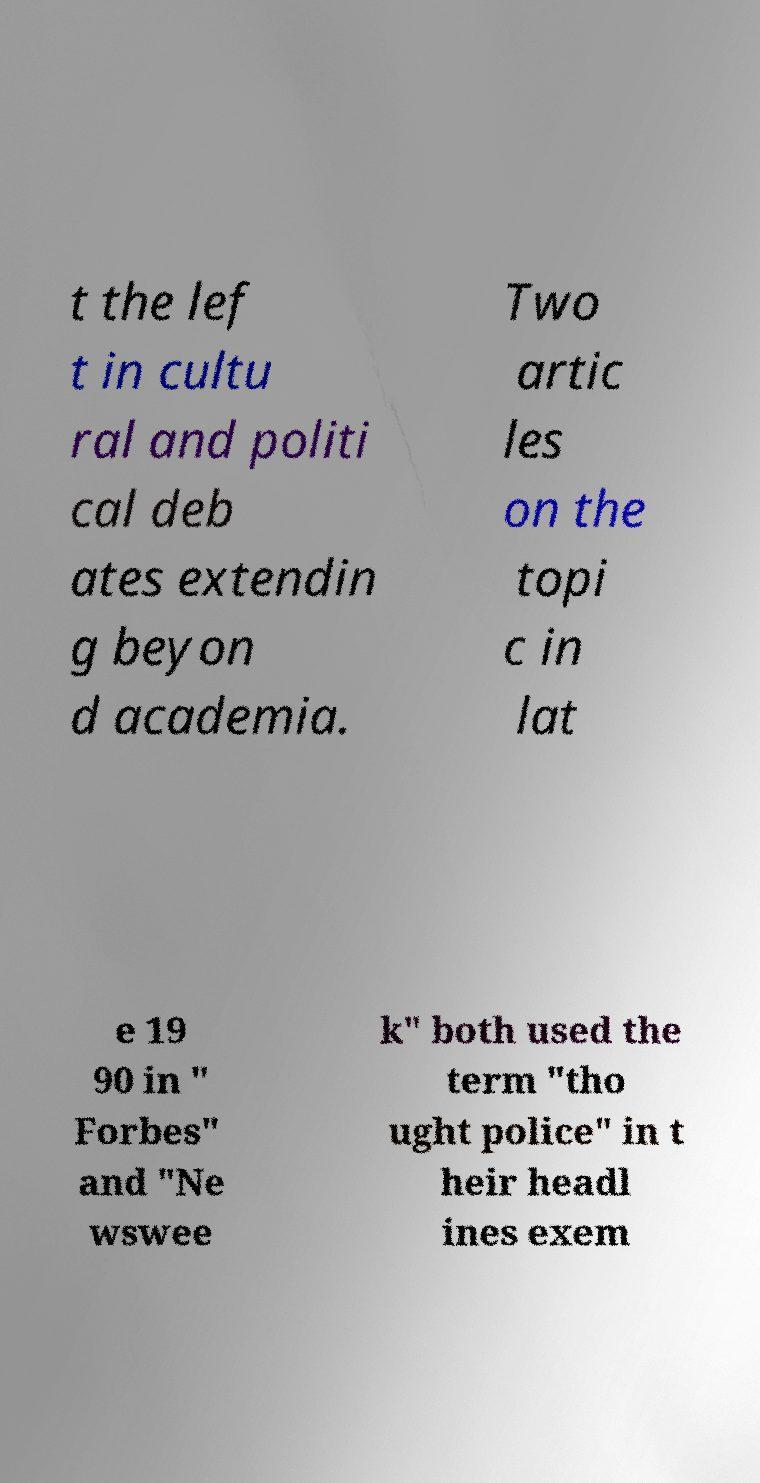Can you read and provide the text displayed in the image?This photo seems to have some interesting text. Can you extract and type it out for me? t the lef t in cultu ral and politi cal deb ates extendin g beyon d academia. Two artic les on the topi c in lat e 19 90 in " Forbes" and "Ne wswee k" both used the term "tho ught police" in t heir headl ines exem 